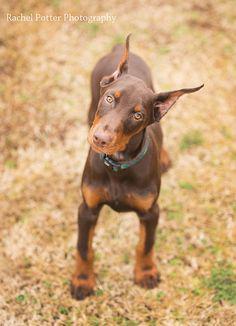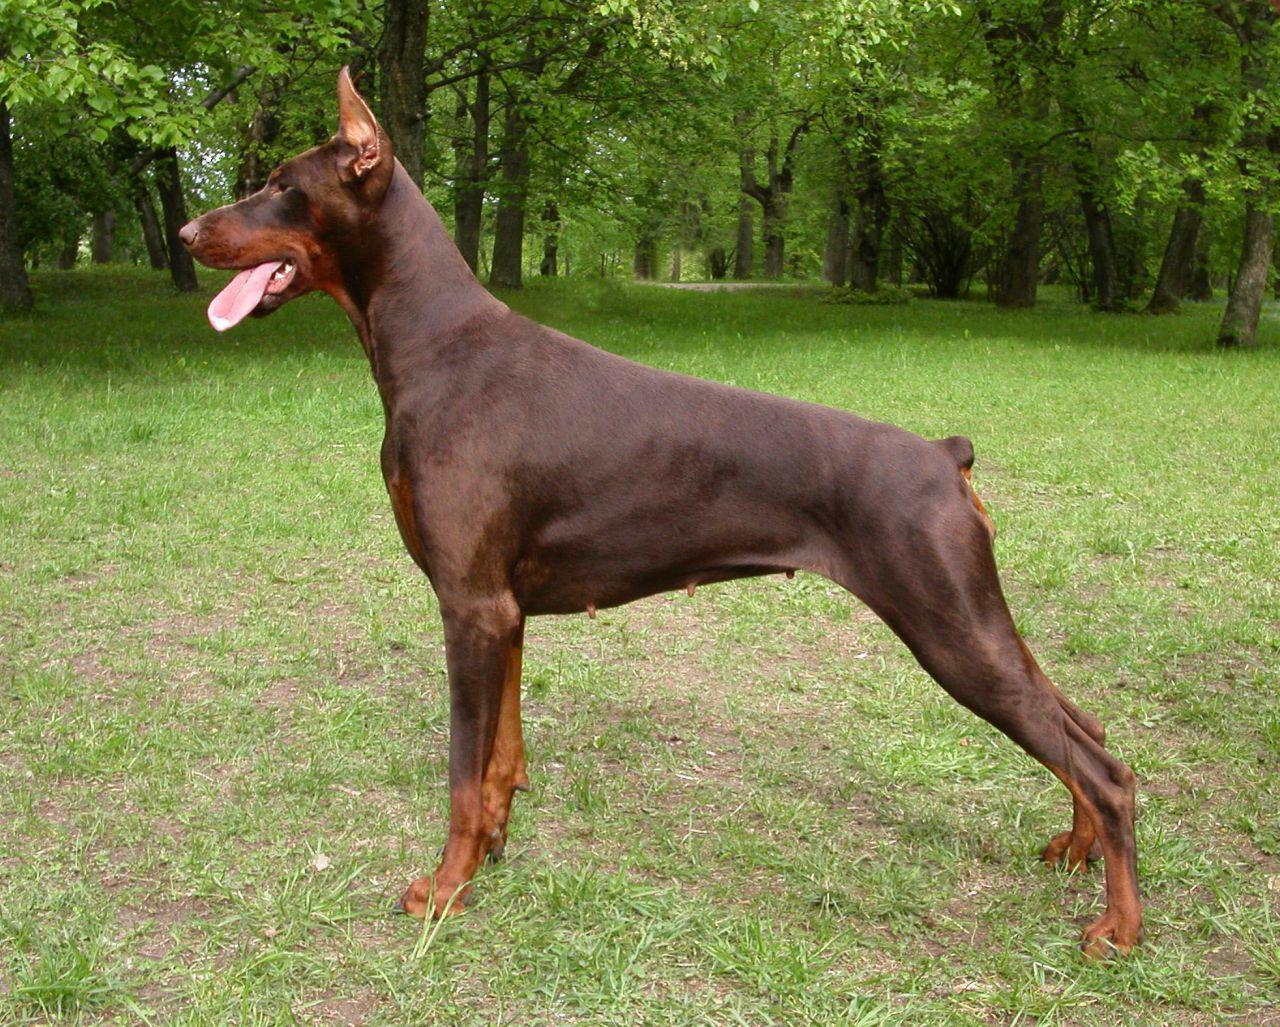The first image is the image on the left, the second image is the image on the right. Analyze the images presented: Is the assertion "There is a total of two brown dogs." valid? Answer yes or no. Yes. The first image is the image on the left, the second image is the image on the right. Examine the images to the left and right. Is the description "There are exactly two dogs." accurate? Answer yes or no. Yes. 